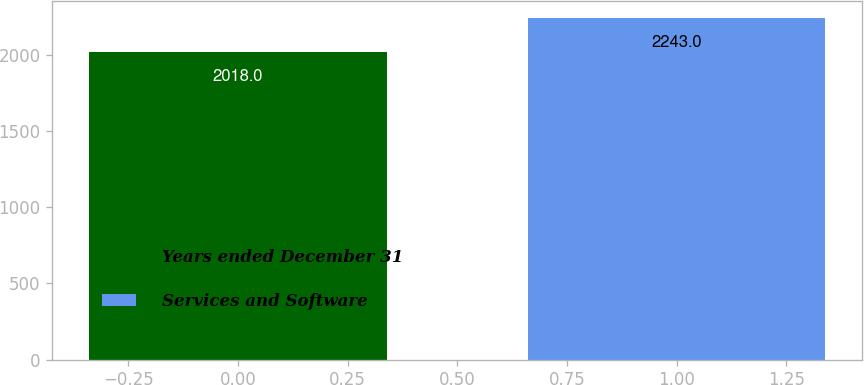<chart> <loc_0><loc_0><loc_500><loc_500><bar_chart><fcel>Years ended December 31<fcel>Services and Software<nl><fcel>2018<fcel>2243<nl></chart> 